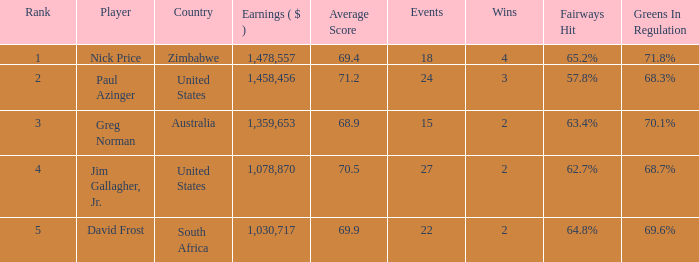How many events have earnings less than 1,030,717? 0.0. 